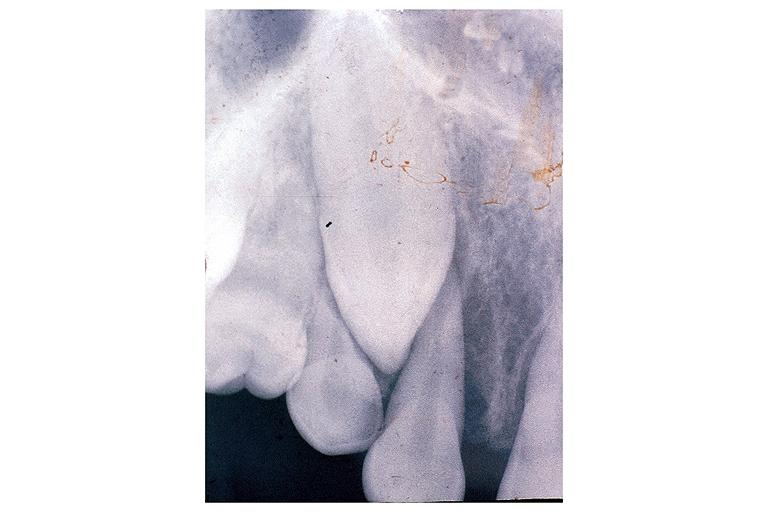what does this image show?
Answer the question using a single word or phrase. Osteosarcoma 